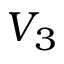Convert formula to latex. <formula><loc_0><loc_0><loc_500><loc_500>V _ { 3 }</formula> 